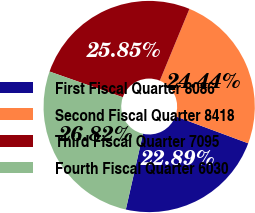Convert chart. <chart><loc_0><loc_0><loc_500><loc_500><pie_chart><fcel>First Fiscal Quarter 8086<fcel>Second Fiscal Quarter 8418<fcel>Third Fiscal Quarter 7095<fcel>Fourth Fiscal Quarter 6030<nl><fcel>22.89%<fcel>24.44%<fcel>25.85%<fcel>26.82%<nl></chart> 